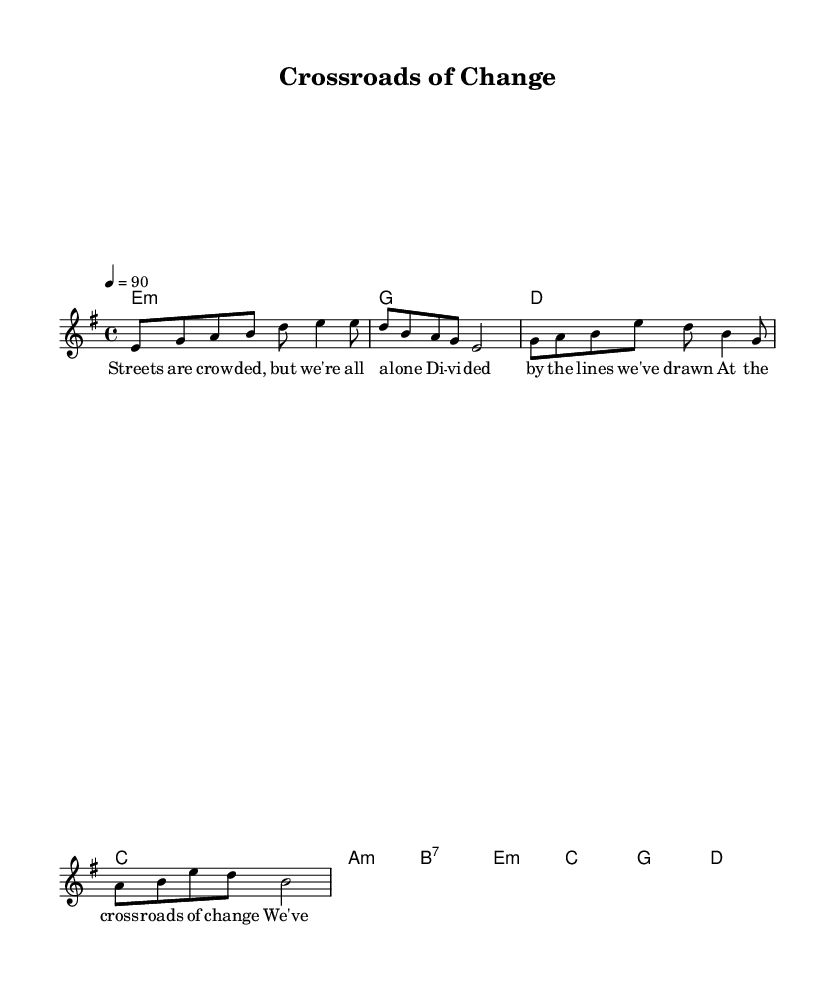What is the key signature of this music? The key signature is E minor, which is indicated by a single sharp (F#) in the key signature position.
Answer: E minor What is the time signature of the music? The time signature is 4/4, shown at the beginning of the score, indicating four beats per measure.
Answer: 4/4 What tempo marking is indicated for this piece? The tempo marking is 90 beats per minute, denoted at the beginning of the score with "4 = 90," which suggests a moderate tempo.
Answer: 90 How many lines are in the verse lyrics? The verse lyrics consist of two lines, as seen in the music sheet layout where the text is divided into separate lines to align with the melody.
Answer: 2 lines What is the tonal relationship between the verse and chorus chords? The verse uses minor chords primarily, while the chorus uses a mix of minor and major chords, creating a contrast that enhances emotional expression prevalent in blues.
Answer: Contrast What social issue is suggested in the verse lyrics? The lyrics mention "Streets are crowded, but we're all alone," hinting at themes of isolation and division in society, which reflects social issues such as urbanization and disconnection.
Answer: Isolation What transformative aspect is hinted at in the chorus lyrics? The chorus refers to "the crossroads of change," suggesting a moment of decision and transformation in social or cultural contexts, indicative of the evolving blues rock genre.
Answer: Transformation 